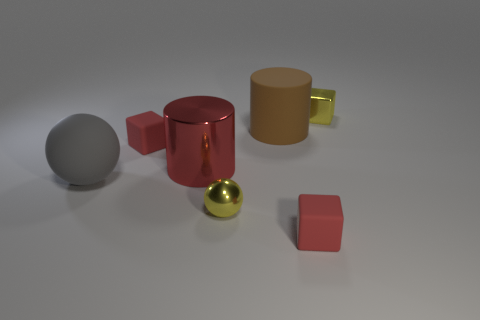Subtract all small yellow cubes. How many cubes are left? 2 Add 1 metal cubes. How many objects exist? 8 Subtract all brown cylinders. How many cylinders are left? 1 Subtract all spheres. How many objects are left? 5 Subtract 1 balls. How many balls are left? 1 Add 1 gray rubber objects. How many gray rubber objects exist? 2 Subtract 0 purple cylinders. How many objects are left? 7 Subtract all yellow cubes. Subtract all brown spheres. How many cubes are left? 2 Subtract all blue spheres. How many green cylinders are left? 0 Subtract all green rubber things. Subtract all red rubber cubes. How many objects are left? 5 